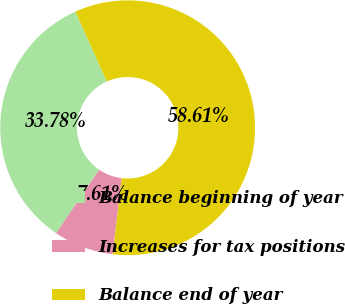Convert chart to OTSL. <chart><loc_0><loc_0><loc_500><loc_500><pie_chart><fcel>Balance beginning of year<fcel>Increases for tax positions<fcel>Balance end of year<nl><fcel>33.78%<fcel>7.61%<fcel>58.61%<nl></chart> 